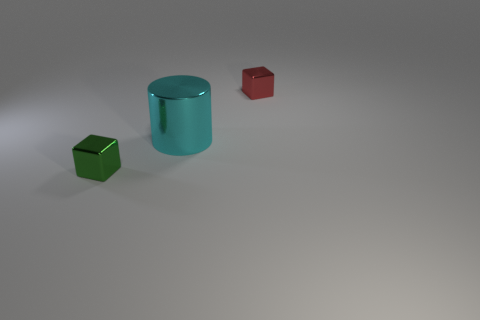What number of small things are green things or cyan cylinders?
Ensure brevity in your answer.  1. How many objects are either tiny things left of the large cyan cylinder or cubes left of the small red metal cube?
Your answer should be very brief. 1. Is the number of cyan cylinders less than the number of tiny metallic blocks?
Your answer should be very brief. Yes. How many other objects are there of the same color as the big object?
Your answer should be very brief. 0. How many tiny green matte spheres are there?
Your response must be concise. 0. What number of metal things are both in front of the tiny red block and right of the green metal block?
Make the answer very short. 1. What is the green thing made of?
Your answer should be compact. Metal. Is there a small yellow shiny thing?
Your response must be concise. No. What color is the metal thing that is in front of the shiny cylinder?
Make the answer very short. Green. There is a small red object behind the large cyan object that is left of the red shiny object; what number of tiny objects are in front of it?
Ensure brevity in your answer.  1. 